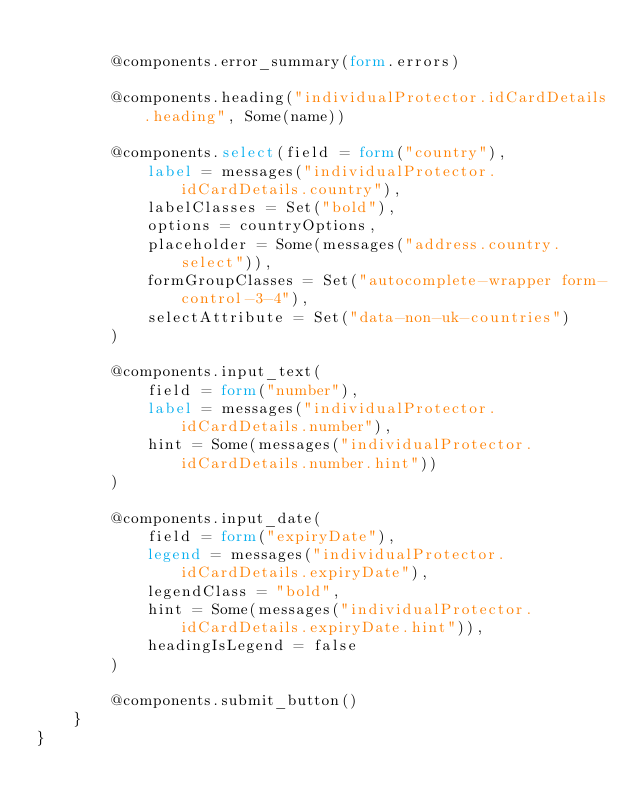Convert code to text. <code><loc_0><loc_0><loc_500><loc_500><_HTML_>
        @components.error_summary(form.errors)

        @components.heading("individualProtector.idCardDetails.heading", Some(name))

        @components.select(field = form("country"),
            label = messages("individualProtector.idCardDetails.country"),
            labelClasses = Set("bold"),
            options = countryOptions,
            placeholder = Some(messages("address.country.select")),
            formGroupClasses = Set("autocomplete-wrapper form-control-3-4"),
            selectAttribute = Set("data-non-uk-countries")
        )

        @components.input_text(
            field = form("number"),
            label = messages("individualProtector.idCardDetails.number"),
            hint = Some(messages("individualProtector.idCardDetails.number.hint"))
        )

        @components.input_date(
            field = form("expiryDate"),
            legend = messages("individualProtector.idCardDetails.expiryDate"),
            legendClass = "bold",
            hint = Some(messages("individualProtector.idCardDetails.expiryDate.hint")),
            headingIsLegend = false
        )

        @components.submit_button()
    }
}
</code> 